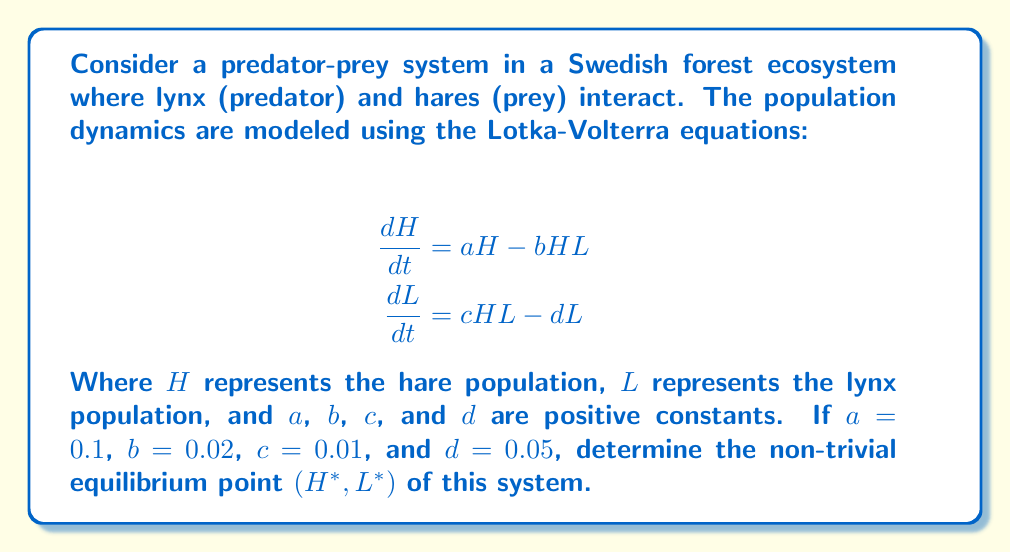Provide a solution to this math problem. To find the non-trivial equilibrium point, we need to set both equations equal to zero and solve for $H$ and $L$:

1) Set $\frac{dH}{dt} = 0$:
   $$0 = aH - bHL$$
   $$aH = bHL$$
   $$a = bL$$ (assuming $H \neq 0$)
   $$L^* = \frac{a}{b} = \frac{0.1}{0.02} = 5$$

2) Set $\frac{dL}{dt} = 0$:
   $$0 = cHL - dL$$
   $$cH = d$$ (assuming $L \neq 0$)
   $$H^* = \frac{d}{c} = \frac{0.05}{0.01} = 5$$

3) The non-trivial equilibrium point is therefore $(H^*, L^*) = (5, 5)$.

This equilibrium point represents a state where both populations coexist without changing over time, which is of particular interest in studying the long-term behavior of predator-prey systems in ecosystems like Swedish forests.
Answer: $(5, 5)$ 